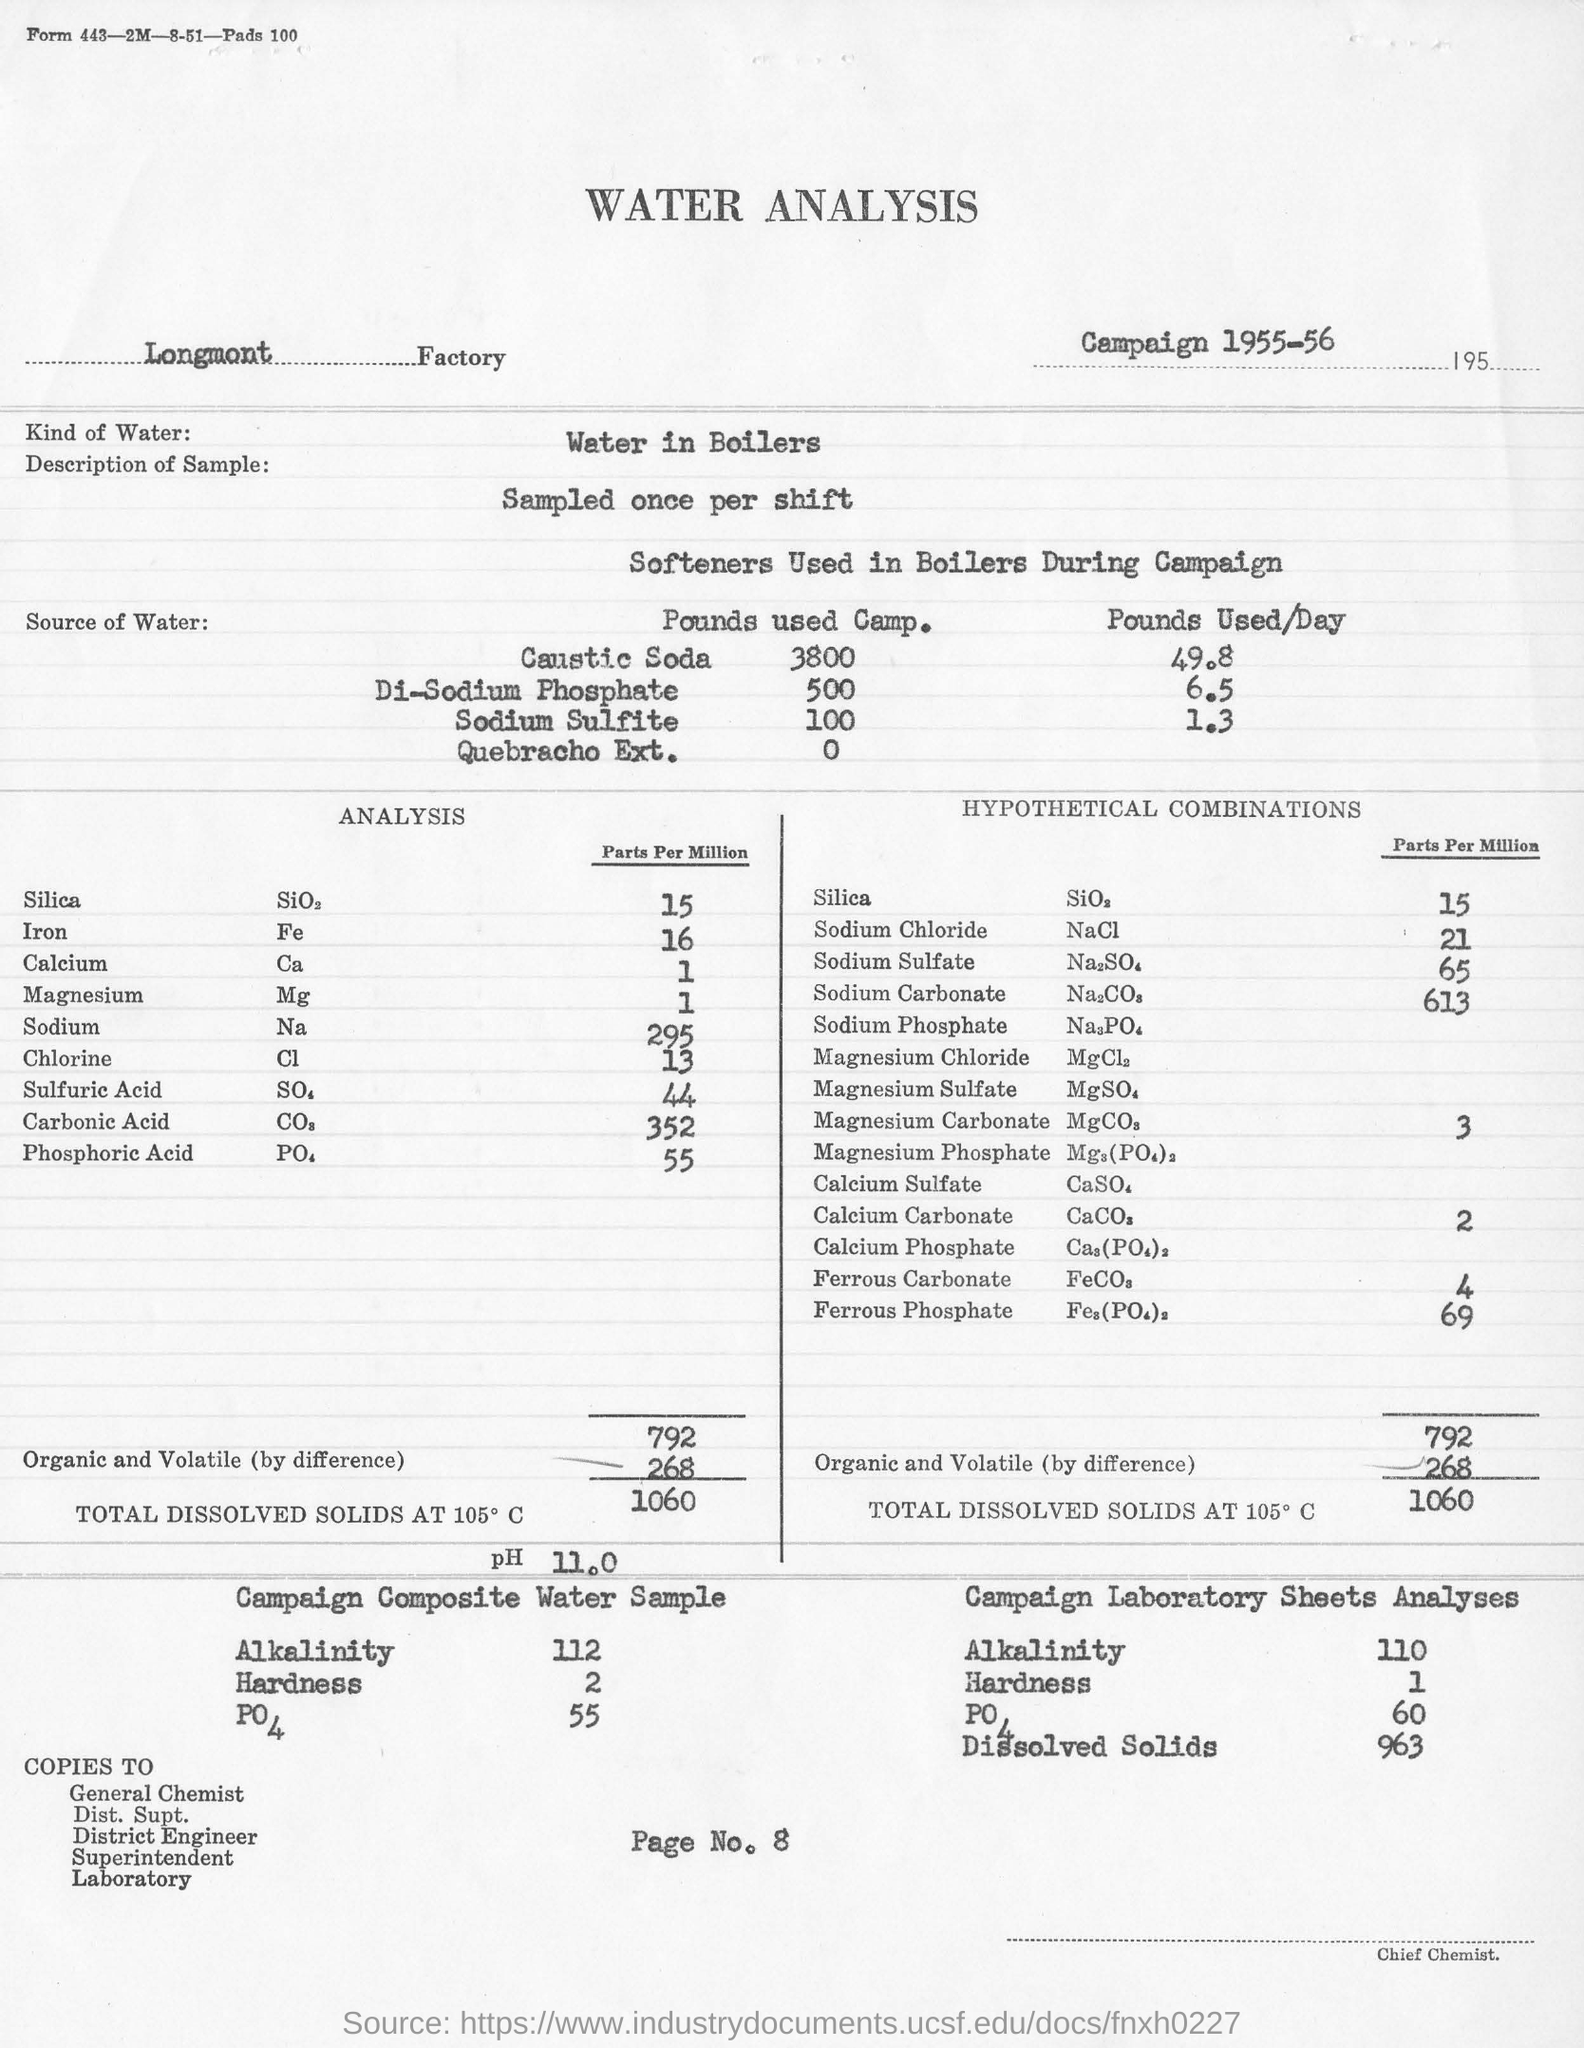Which analysis is mentioned in this document?
Provide a short and direct response. WATER ANALYSIS. What kind of water is used for analysis?
Your answer should be very brief. Water in Boilers. In which Factory is the analysis conducted?
Your response must be concise. Longmont   Factory. What is the concentration of Silica in Parts Per Million in the analysis?
Ensure brevity in your answer.  15. What is the concentration of Sodium in Parts Per Million in the analysis?
Offer a very short reply. 295. What is the concentration of NaCL in Parts per Million in the analysis?
Keep it short and to the point. 21. What is the alkalinity of the Campaign Composite Water Sample?
Ensure brevity in your answer.  112. What is the hardness of Campaign Composite Water Sample?
Your answer should be compact. 2. 